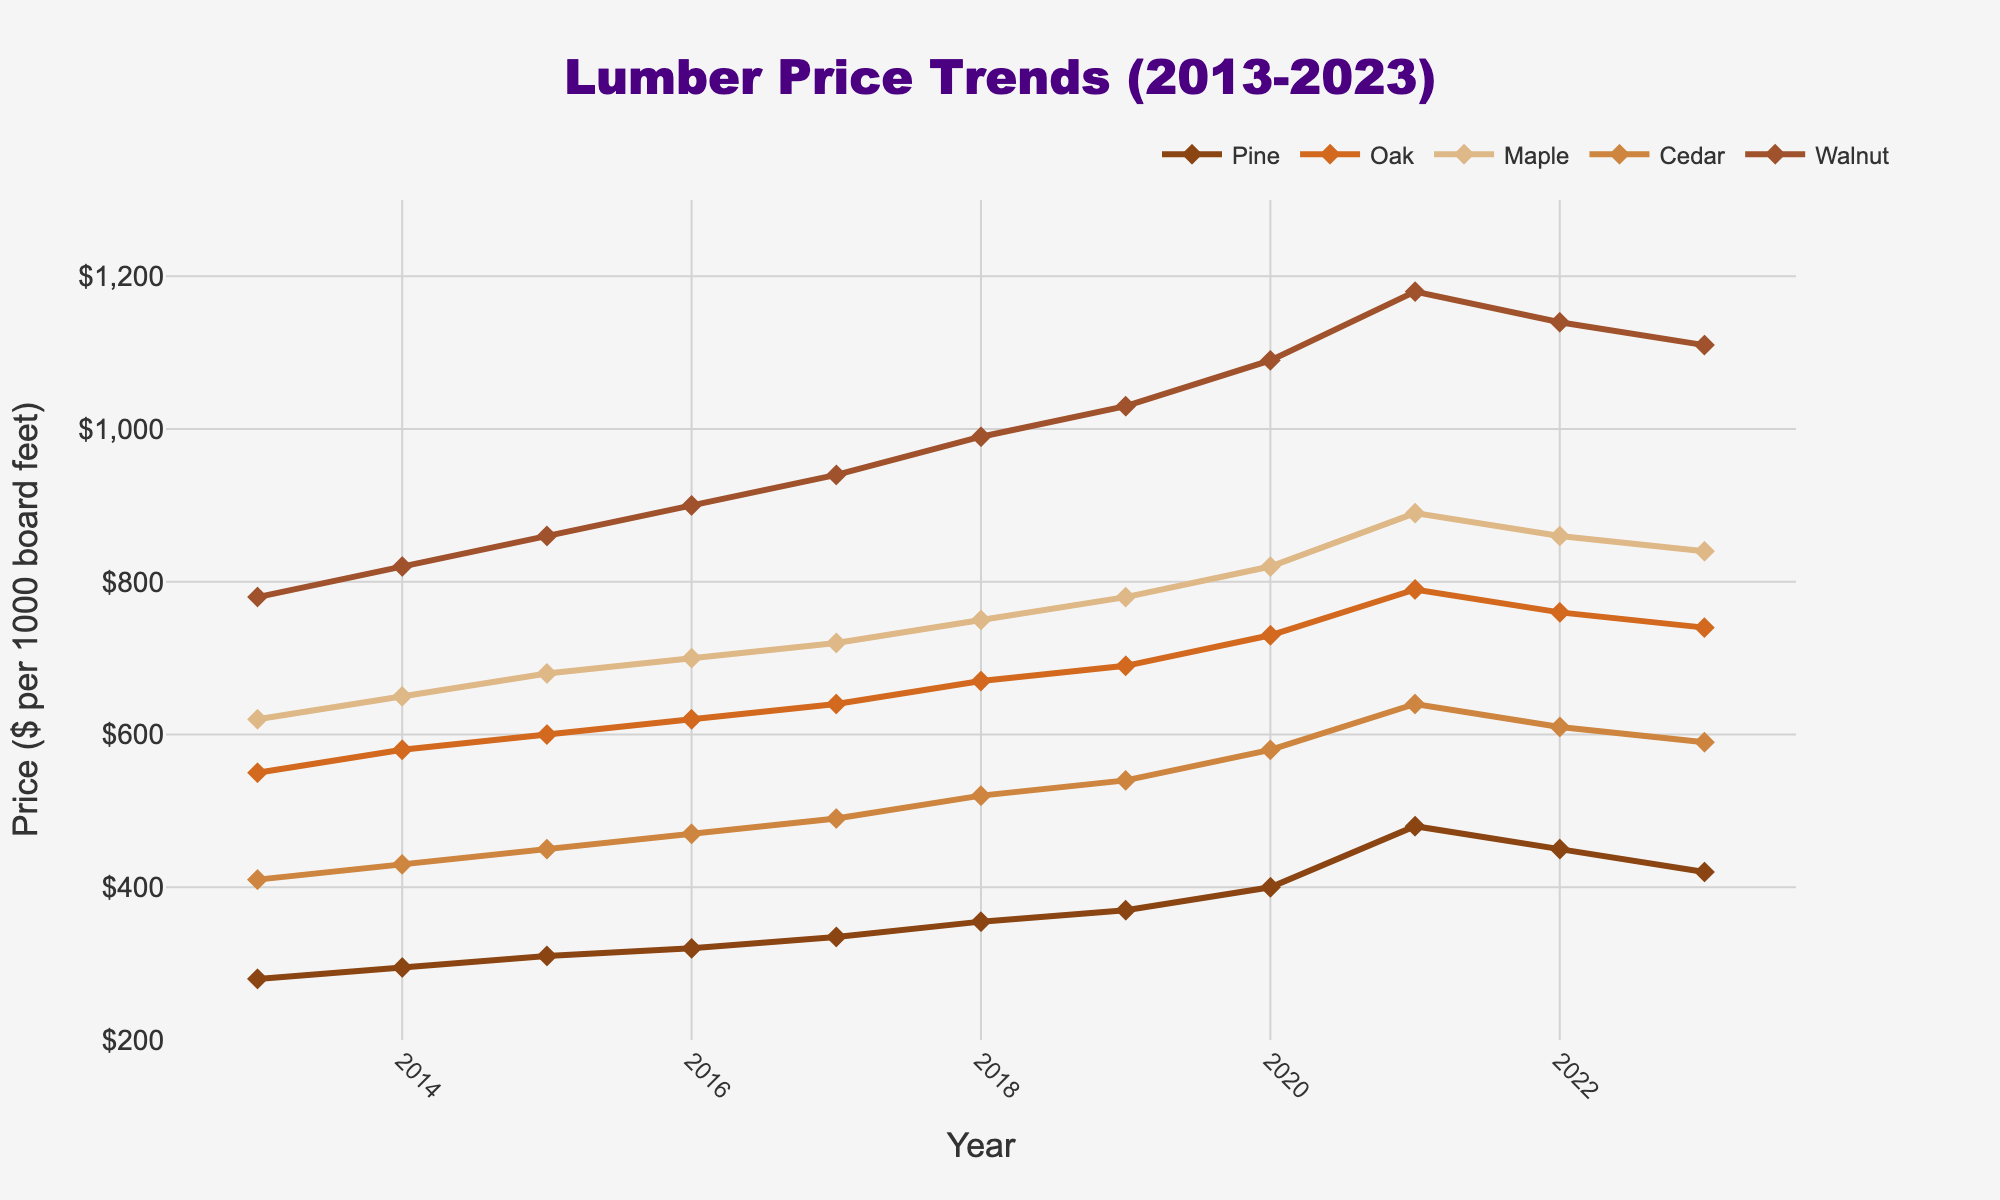What was the price trend for Pine from 2013 to 2023? The prices of Pine increase steadily from 280 in 2013 to a peak of 480 in 2021 before dropping to 420 by 2023.
Answer: An initial rise and then a drop after 2021 What is the average price of Oak over the decade? Sum the annual prices of Oak from 2013 to 2023 and divide by the number of years (7250/11).
Answer: $659.09 Which wood type had the most significant price increase between 2013 and 2023? Calculate the difference between prices in 2023 and 2013 for each wood type. Walnut increased the most (1110 - 780 = 330).
Answer: Walnut How did the price of Maple change from 2019 to 2022? Maple's price increased from 780 in 2019 to 890 in 2021 and then decreased to 860 in 2022, a general upward trend with a slight drop.
Answer: Initial rise, slight drop Which wood type had the highest price in 2021 and by how much? In 2021, Walnut had the highest price of 1180.
Answer: Walnut, $1180 Compare the prices of Pine and Cedar in 2020. Which one was higher and by how much? Pine was priced at 400, and Cedar at 580 in 2020. The difference is 580 - 400.
Answer: Cedar, $180 Did any wood type experience a decrease in price from 2021 to 2023? Which one(s)? Both Pine and Cedar experienced price decreases from 2021 to 2023, from 480 to 420 and 640 to 590, respectively.
Answer: Pine and Cedar Among Pine, Oak, and Maple, which one had the steadiest increase in price over the decade? Maple experienced consistent growth each year without any drops from 620 in 2013 to 890 in 2021 and 840 in 2023.
Answer: Maple What is the 5-year average price for Cedar from 2019 to 2023? Calculate the average of Cedar prices from 2019 to 2023: (540 + 580 + 640 + 610 + 590) / 5 = 592.
Answer: $592 Between which consecutive years did Oak see its largest price jump? Oak's largest price jump occurred between 2020 and 2021, from 730 to 790, a difference of 60.
Answer: 2020 to 2021 